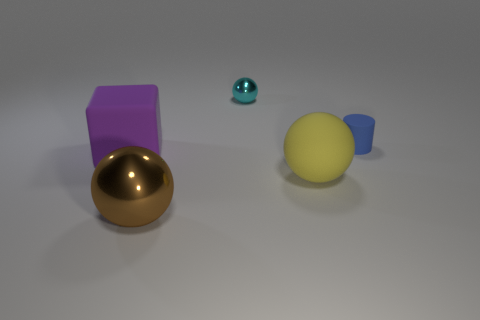Subtract all shiny spheres. How many spheres are left? 1 Subtract all cyan spheres. How many spheres are left? 2 Add 2 tiny rubber things. How many objects exist? 7 Subtract 0 gray balls. How many objects are left? 5 Subtract all cylinders. How many objects are left? 4 Subtract 1 cylinders. How many cylinders are left? 0 Subtract all gray balls. Subtract all red cylinders. How many balls are left? 3 Subtract all red cylinders. How many yellow cubes are left? 0 Subtract all big purple cubes. Subtract all tiny things. How many objects are left? 2 Add 1 tiny blue rubber cylinders. How many tiny blue rubber cylinders are left? 2 